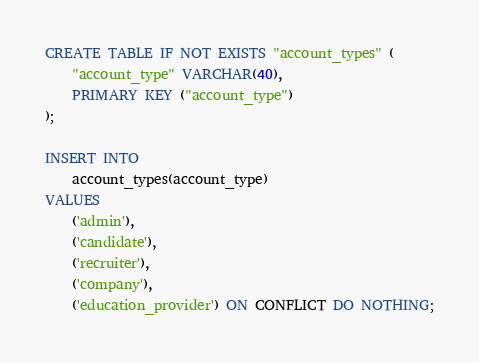<code> <loc_0><loc_0><loc_500><loc_500><_SQL_>CREATE TABLE IF NOT EXISTS "account_types" (
    "account_type" VARCHAR(40),
    PRIMARY KEY ("account_type")
);

INSERT INTO
    account_types(account_type)
VALUES
    ('admin'),
    ('candidate'),
    ('recruiter'),
    ('company'),
    ('education_provider') ON CONFLICT DO NOTHING;</code> 